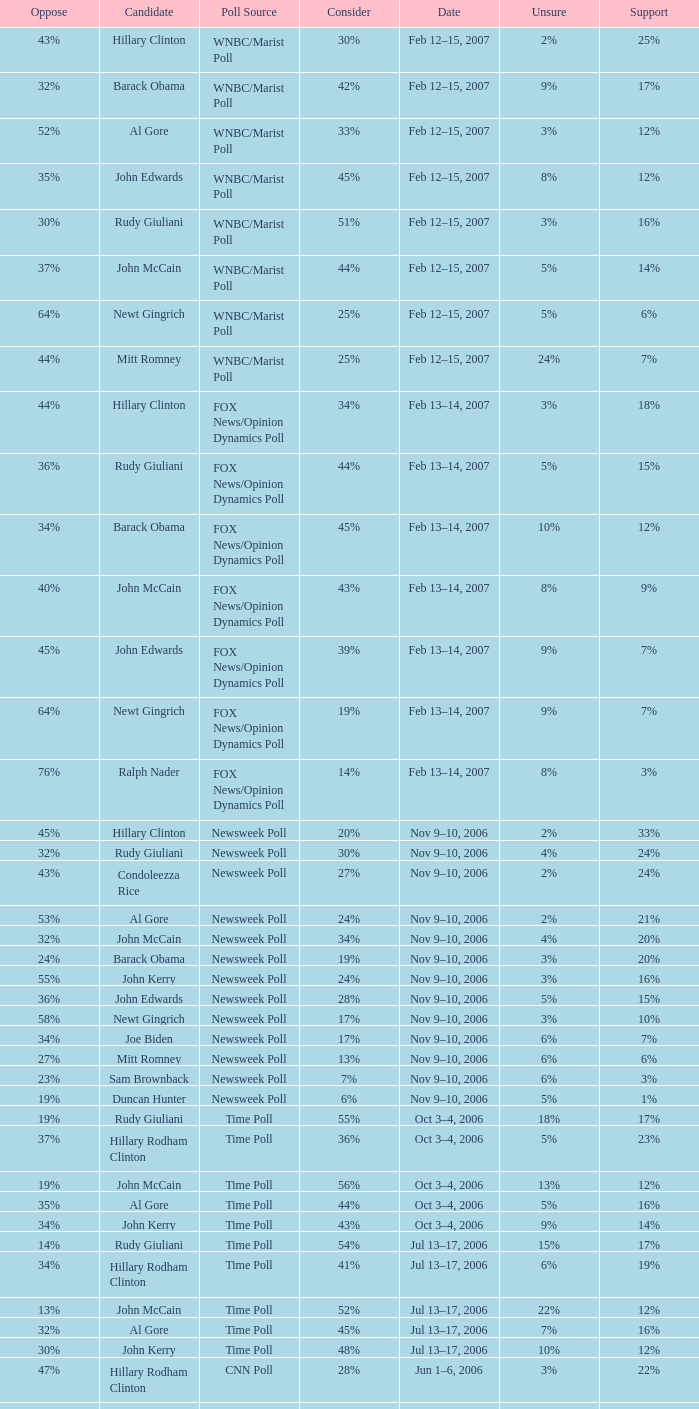What percentage of people said they would consider Rudy Giuliani as a candidate according to the Newsweek poll that showed 32% opposed him? 30%. Can you parse all the data within this table? {'header': ['Oppose', 'Candidate', 'Poll Source', 'Consider', 'Date', 'Unsure', 'Support'], 'rows': [['43%', 'Hillary Clinton', 'WNBC/Marist Poll', '30%', 'Feb 12–15, 2007', '2%', '25%'], ['32%', 'Barack Obama', 'WNBC/Marist Poll', '42%', 'Feb 12–15, 2007', '9%', '17%'], ['52%', 'Al Gore', 'WNBC/Marist Poll', '33%', 'Feb 12–15, 2007', '3%', '12%'], ['35%', 'John Edwards', 'WNBC/Marist Poll', '45%', 'Feb 12–15, 2007', '8%', '12%'], ['30%', 'Rudy Giuliani', 'WNBC/Marist Poll', '51%', 'Feb 12–15, 2007', '3%', '16%'], ['37%', 'John McCain', 'WNBC/Marist Poll', '44%', 'Feb 12–15, 2007', '5%', '14%'], ['64%', 'Newt Gingrich', 'WNBC/Marist Poll', '25%', 'Feb 12–15, 2007', '5%', '6%'], ['44%', 'Mitt Romney', 'WNBC/Marist Poll', '25%', 'Feb 12–15, 2007', '24%', '7%'], ['44%', 'Hillary Clinton', 'FOX News/Opinion Dynamics Poll', '34%', 'Feb 13–14, 2007', '3%', '18%'], ['36%', 'Rudy Giuliani', 'FOX News/Opinion Dynamics Poll', '44%', 'Feb 13–14, 2007', '5%', '15%'], ['34%', 'Barack Obama', 'FOX News/Opinion Dynamics Poll', '45%', 'Feb 13–14, 2007', '10%', '12%'], ['40%', 'John McCain', 'FOX News/Opinion Dynamics Poll', '43%', 'Feb 13–14, 2007', '8%', '9%'], ['45%', 'John Edwards', 'FOX News/Opinion Dynamics Poll', '39%', 'Feb 13–14, 2007', '9%', '7%'], ['64%', 'Newt Gingrich', 'FOX News/Opinion Dynamics Poll', '19%', 'Feb 13–14, 2007', '9%', '7%'], ['76%', 'Ralph Nader', 'FOX News/Opinion Dynamics Poll', '14%', 'Feb 13–14, 2007', '8%', '3%'], ['45%', 'Hillary Clinton', 'Newsweek Poll', '20%', 'Nov 9–10, 2006', '2%', '33%'], ['32%', 'Rudy Giuliani', 'Newsweek Poll', '30%', 'Nov 9–10, 2006', '4%', '24%'], ['43%', 'Condoleezza Rice', 'Newsweek Poll', '27%', 'Nov 9–10, 2006', '2%', '24%'], ['53%', 'Al Gore', 'Newsweek Poll', '24%', 'Nov 9–10, 2006', '2%', '21%'], ['32%', 'John McCain', 'Newsweek Poll', '34%', 'Nov 9–10, 2006', '4%', '20%'], ['24%', 'Barack Obama', 'Newsweek Poll', '19%', 'Nov 9–10, 2006', '3%', '20%'], ['55%', 'John Kerry', 'Newsweek Poll', '24%', 'Nov 9–10, 2006', '3%', '16%'], ['36%', 'John Edwards', 'Newsweek Poll', '28%', 'Nov 9–10, 2006', '5%', '15%'], ['58%', 'Newt Gingrich', 'Newsweek Poll', '17%', 'Nov 9–10, 2006', '3%', '10%'], ['34%', 'Joe Biden', 'Newsweek Poll', '17%', 'Nov 9–10, 2006', '6%', '7%'], ['27%', 'Mitt Romney', 'Newsweek Poll', '13%', 'Nov 9–10, 2006', '6%', '6%'], ['23%', 'Sam Brownback', 'Newsweek Poll', '7%', 'Nov 9–10, 2006', '6%', '3%'], ['19%', 'Duncan Hunter', 'Newsweek Poll', '6%', 'Nov 9–10, 2006', '5%', '1%'], ['19%', 'Rudy Giuliani', 'Time Poll', '55%', 'Oct 3–4, 2006', '18%', '17%'], ['37%', 'Hillary Rodham Clinton', 'Time Poll', '36%', 'Oct 3–4, 2006', '5%', '23%'], ['19%', 'John McCain', 'Time Poll', '56%', 'Oct 3–4, 2006', '13%', '12%'], ['35%', 'Al Gore', 'Time Poll', '44%', 'Oct 3–4, 2006', '5%', '16%'], ['34%', 'John Kerry', 'Time Poll', '43%', 'Oct 3–4, 2006', '9%', '14%'], ['14%', 'Rudy Giuliani', 'Time Poll', '54%', 'Jul 13–17, 2006', '15%', '17%'], ['34%', 'Hillary Rodham Clinton', 'Time Poll', '41%', 'Jul 13–17, 2006', '6%', '19%'], ['13%', 'John McCain', 'Time Poll', '52%', 'Jul 13–17, 2006', '22%', '12%'], ['32%', 'Al Gore', 'Time Poll', '45%', 'Jul 13–17, 2006', '7%', '16%'], ['30%', 'John Kerry', 'Time Poll', '48%', 'Jul 13–17, 2006', '10%', '12%'], ['47%', 'Hillary Rodham Clinton', 'CNN Poll', '28%', 'Jun 1–6, 2006', '3%', '22%'], ['48%', 'Al Gore', 'CNN Poll', '32%', 'Jun 1–6, 2006', '3%', '17%'], ['47%', 'John Kerry', 'CNN Poll', '35%', 'Jun 1–6, 2006', '4%', '14%'], ['30%', 'Rudolph Giuliani', 'CNN Poll', '45%', 'Jun 1–6, 2006', '6%', '19%'], ['34%', 'John McCain', 'CNN Poll', '48%', 'Jun 1–6, 2006', '6%', '12%'], ['63%', 'Jeb Bush', 'CNN Poll', '26%', 'Jun 1–6, 2006', '2%', '9%'], ['42%', 'Hillary Clinton', 'ABC News/Washington Post Poll', '38%', 'May 11–15, 2006', '1%', '19%'], ['28%', 'John McCain', 'ABC News/Washington Post Poll', '57%', 'May 11–15, 2006', '6%', '9%'], ['44%', 'Hillary Clinton', 'FOX News/Opinion Dynamics Poll', '19%', 'Feb 7–8, 2006', '2%', '35%'], ['24%', 'Rudy Giuliani', 'FOX News/Opinion Dynamics Poll', '38%', 'Feb 7–8, 2006', '6%', '33%'], ['22%', 'John McCain', 'FOX News/Opinion Dynamics Poll', '40%', 'Feb 7–8, 2006', '7%', '30%'], ['45%', 'John Kerry', 'FOX News/Opinion Dynamics Poll', '23%', 'Feb 7–8, 2006', '3%', '29%'], ['46%', 'Condoleezza Rice', 'FOX News/Opinion Dynamics Poll', '38%', 'Feb 7–8, 2006', '3%', '14%'], ['51%', 'Hillary Rodham Clinton', 'CNN/USA Today/Gallup Poll', '32%', 'Jan 20–22, 2006', '1%', '16%'], ['15%', 'John McCain', 'Diageo/Hotline Poll', '46%', 'Nov 11–15, 2005', '15%', '23%'], ['40%', 'Hillary Rodham Clinton', 'CNN/USA Today/Gallup Poll', '31%', 'May 20–22, 2005', '1%', '28%'], ['45%', 'Hillary Rodham Clinton', 'CNN/USA Today/Gallup Poll', '33%', 'Jun 9–10, 2003', '2%', '20%']]} 